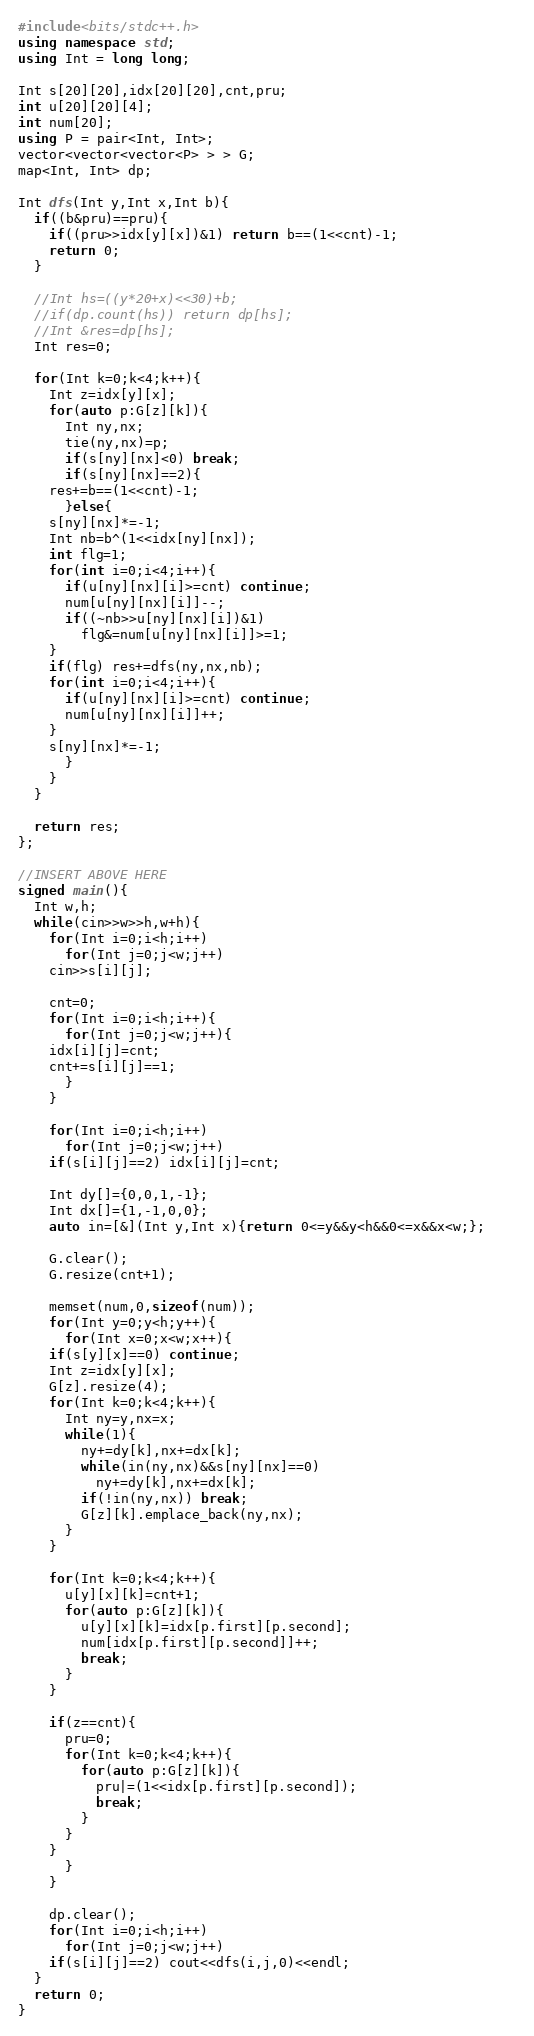Convert code to text. <code><loc_0><loc_0><loc_500><loc_500><_C++_>#include<bits/stdc++.h>
using namespace std;
using Int = long long;

Int s[20][20],idx[20][20],cnt,pru;
int u[20][20][4];
int num[20];
using P = pair<Int, Int>;
vector<vector<vector<P> > > G;
map<Int, Int> dp;

Int dfs(Int y,Int x,Int b){
  if((b&pru)==pru){
    if((pru>>idx[y][x])&1) return b==(1<<cnt)-1;
    return 0;
  }
  
  //Int hs=((y*20+x)<<30)+b;
  //if(dp.count(hs)) return dp[hs];
  //Int &res=dp[hs];
  Int res=0;
  
  for(Int k=0;k<4;k++){
    Int z=idx[y][x];
    for(auto p:G[z][k]){
      Int ny,nx;
      tie(ny,nx)=p;
      if(s[ny][nx]<0) break;
      if(s[ny][nx]==2){
	res+=b==(1<<cnt)-1;
      }else{
	s[ny][nx]*=-1;
	Int nb=b^(1<<idx[ny][nx]);
	int flg=1;
	for(int i=0;i<4;i++){
	  if(u[ny][nx][i]>=cnt) continue; 
	  num[u[ny][nx][i]]--;
	  if((~nb>>u[ny][nx][i])&1)
	    flg&=num[u[ny][nx][i]]>=1;
	}
	if(flg) res+=dfs(ny,nx,nb);
	for(int i=0;i<4;i++){
	  if(u[ny][nx][i]>=cnt) continue; 
	  num[u[ny][nx][i]]++;
	}
	s[ny][nx]*=-1;
      }
    }
  }
	
  return res;
};

//INSERT ABOVE HERE
signed main(){
  Int w,h;
  while(cin>>w>>h,w+h){
    for(Int i=0;i<h;i++)
      for(Int j=0;j<w;j++)
	cin>>s[i][j];
    
    cnt=0;
    for(Int i=0;i<h;i++){
      for(Int j=0;j<w;j++){
	idx[i][j]=cnt;
	cnt+=s[i][j]==1;
      }
    }
    
    for(Int i=0;i<h;i++)
      for(Int j=0;j<w;j++)
	if(s[i][j]==2) idx[i][j]=cnt;
    
    Int dy[]={0,0,1,-1};
    Int dx[]={1,-1,0,0};
    auto in=[&](Int y,Int x){return 0<=y&&y<h&&0<=x&&x<w;};    

    G.clear();
    G.resize(cnt+1);
    
    memset(num,0,sizeof(num));    
    for(Int y=0;y<h;y++){
      for(Int x=0;x<w;x++){
	if(s[y][x]==0) continue;
	Int z=idx[y][x];
	G[z].resize(4);
	for(Int k=0;k<4;k++){
	  Int ny=y,nx=x;
	  while(1){
	    ny+=dy[k],nx+=dx[k];
	    while(in(ny,nx)&&s[ny][nx]==0)
	      ny+=dy[k],nx+=dx[k];
	    if(!in(ny,nx)) break;	    
	    G[z][k].emplace_back(ny,nx);
	  }
	}
	
	for(Int k=0;k<4;k++){
	  u[y][x][k]=cnt+1;
	  for(auto p:G[z][k]){
	    u[y][x][k]=idx[p.first][p.second];
	    num[idx[p.first][p.second]]++;
	    break;
	  }
	}
	
	if(z==cnt){
	  pru=0;
	  for(Int k=0;k<4;k++){
	    for(auto p:G[z][k]){
	      pru|=(1<<idx[p.first][p.second]);
	      break;
	    }
	  }
	}
      }
    }

    dp.clear();
    for(Int i=0;i<h;i++)
      for(Int j=0;j<w;j++)
	if(s[i][j]==2) cout<<dfs(i,j,0)<<endl;
  }
  return 0;
}

</code> 